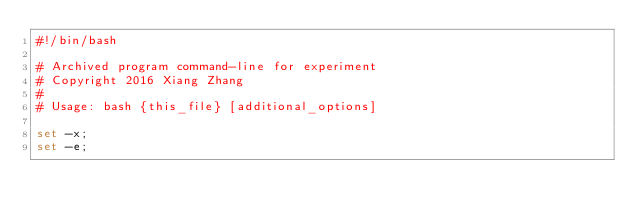<code> <loc_0><loc_0><loc_500><loc_500><_Bash_>#!/bin/bash

# Archived program command-line for experiment
# Copyright 2016 Xiang Zhang
#
# Usage: bash {this_file} [additional_options]

set -x;
set -e;
</code> 